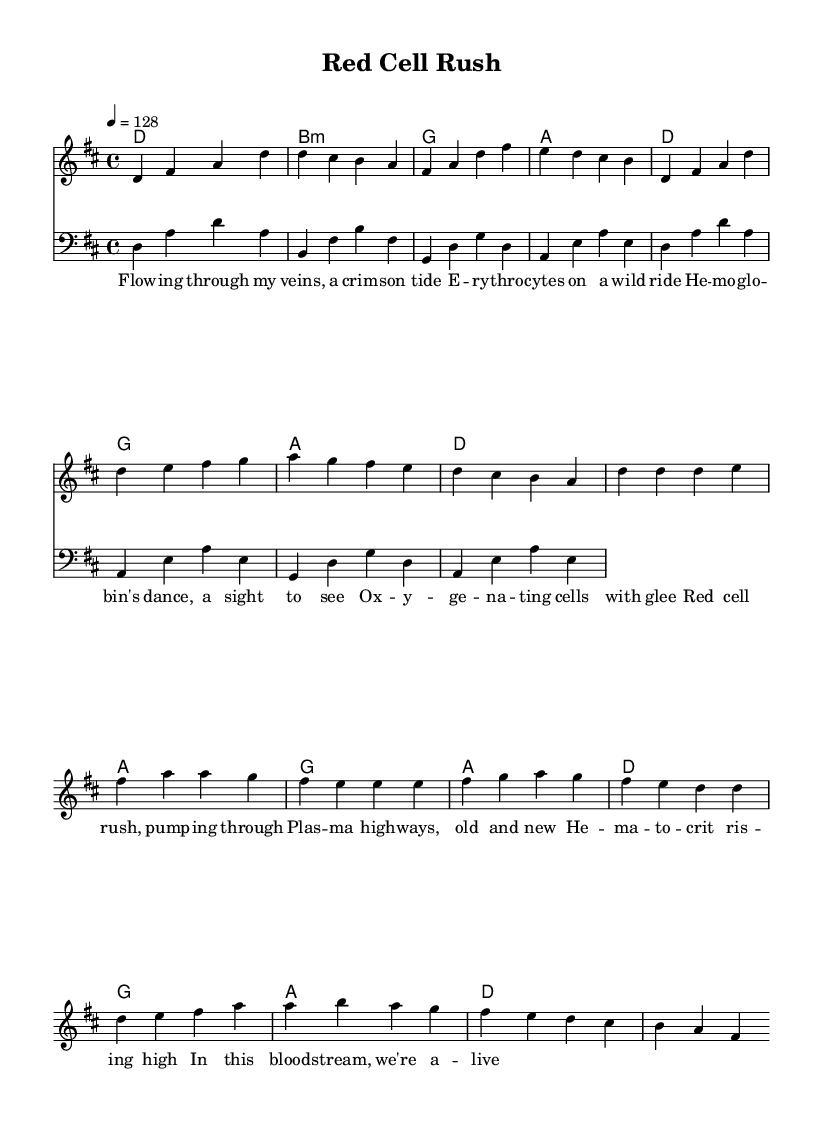What is the key signature of this music? The key signature is indicated at the beginning of the score, showing D major, which has two sharps (F# and C#).
Answer: D major What is the time signature of this music? The time signature, found at the start of the staff, indicates 4/4 time, meaning there are four beats per measure and the quarter note receives one beat.
Answer: 4/4 What is the tempo marking of this piece? The tempo marking is shown as “4 = 128,” indicating that there are 128 beats per minute.
Answer: 128 How many measures are in the verse section? Counting the measures that contain the melody for the verse, there are 8 measures before the transition to the chorus.
Answer: 8 What is the name of the piece? The title of the piece is given in the header section, which is "Red Cell Rush."
Answer: Red Cell Rush Which musical section contains the lyrics "Red cell rush, pumping through"? The lyrics "Red cell rush, pumping through" are located in the chorus section, following the melody of the chorus part.
Answer: Chorus What is repeated multiple times in the chorus? In the chorus, the note D is repeated several times, particularly at the start of the section, indicating its importance in the musical phrase.
Answer: D 